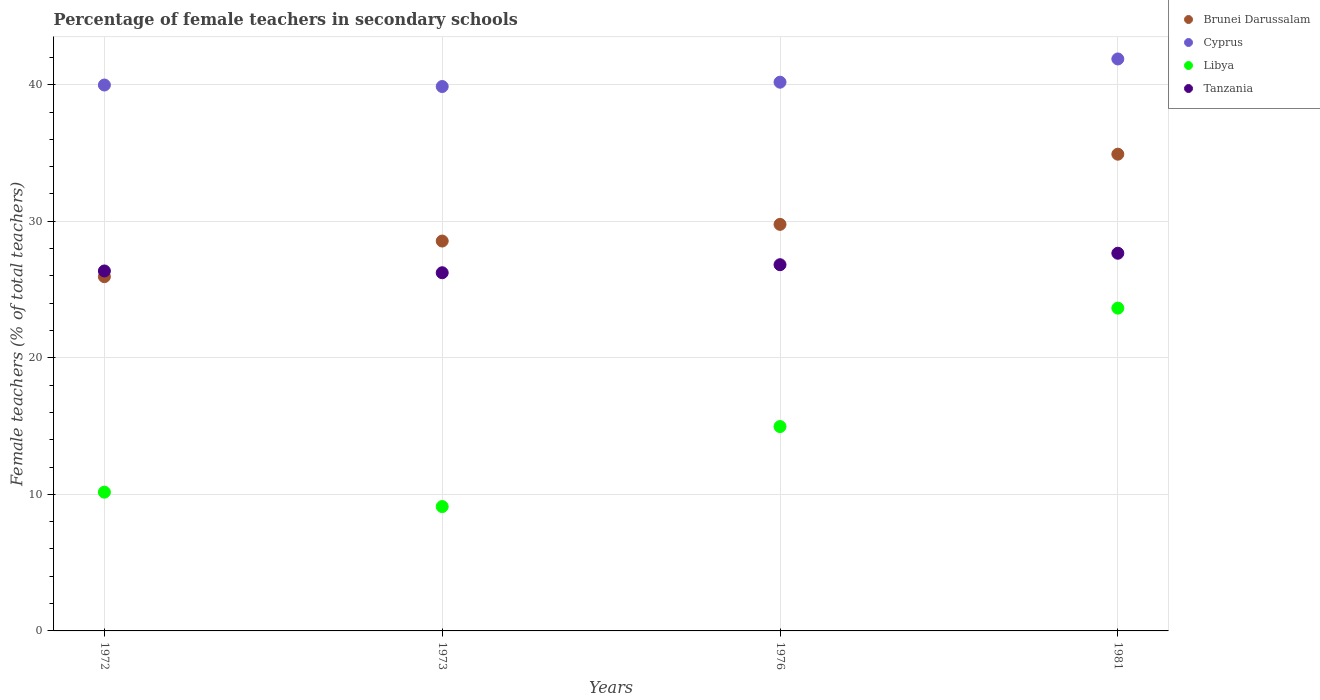Is the number of dotlines equal to the number of legend labels?
Provide a succinct answer. Yes. What is the percentage of female teachers in Cyprus in 1981?
Provide a succinct answer. 41.89. Across all years, what is the maximum percentage of female teachers in Cyprus?
Your answer should be very brief. 41.89. Across all years, what is the minimum percentage of female teachers in Libya?
Offer a very short reply. 9.11. What is the total percentage of female teachers in Tanzania in the graph?
Your answer should be compact. 107.08. What is the difference between the percentage of female teachers in Cyprus in 1973 and that in 1981?
Provide a short and direct response. -2.02. What is the difference between the percentage of female teachers in Cyprus in 1981 and the percentage of female teachers in Brunei Darussalam in 1976?
Your answer should be compact. 12.11. What is the average percentage of female teachers in Libya per year?
Your answer should be compact. 14.47. In the year 1976, what is the difference between the percentage of female teachers in Cyprus and percentage of female teachers in Libya?
Ensure brevity in your answer.  25.22. In how many years, is the percentage of female teachers in Tanzania greater than 30 %?
Provide a short and direct response. 0. What is the ratio of the percentage of female teachers in Brunei Darussalam in 1976 to that in 1981?
Ensure brevity in your answer.  0.85. Is the difference between the percentage of female teachers in Cyprus in 1973 and 1981 greater than the difference between the percentage of female teachers in Libya in 1973 and 1981?
Make the answer very short. Yes. What is the difference between the highest and the second highest percentage of female teachers in Cyprus?
Provide a succinct answer. 1.7. What is the difference between the highest and the lowest percentage of female teachers in Cyprus?
Make the answer very short. 2.02. In how many years, is the percentage of female teachers in Tanzania greater than the average percentage of female teachers in Tanzania taken over all years?
Keep it short and to the point. 2. Is it the case that in every year, the sum of the percentage of female teachers in Libya and percentage of female teachers in Cyprus  is greater than the sum of percentage of female teachers in Tanzania and percentage of female teachers in Brunei Darussalam?
Give a very brief answer. Yes. Is the percentage of female teachers in Libya strictly greater than the percentage of female teachers in Brunei Darussalam over the years?
Your answer should be compact. No. Is the percentage of female teachers in Libya strictly less than the percentage of female teachers in Tanzania over the years?
Offer a terse response. Yes. What is the difference between two consecutive major ticks on the Y-axis?
Make the answer very short. 10. Are the values on the major ticks of Y-axis written in scientific E-notation?
Provide a succinct answer. No. Does the graph contain grids?
Keep it short and to the point. Yes. How are the legend labels stacked?
Provide a succinct answer. Vertical. What is the title of the graph?
Your answer should be compact. Percentage of female teachers in secondary schools. Does "Dominica" appear as one of the legend labels in the graph?
Your response must be concise. No. What is the label or title of the Y-axis?
Make the answer very short. Female teachers (% of total teachers). What is the Female teachers (% of total teachers) in Brunei Darussalam in 1972?
Your answer should be compact. 25.94. What is the Female teachers (% of total teachers) in Cyprus in 1972?
Offer a terse response. 39.98. What is the Female teachers (% of total teachers) of Libya in 1972?
Your answer should be compact. 10.16. What is the Female teachers (% of total teachers) in Tanzania in 1972?
Offer a terse response. 26.36. What is the Female teachers (% of total teachers) in Brunei Darussalam in 1973?
Provide a succinct answer. 28.55. What is the Female teachers (% of total teachers) in Cyprus in 1973?
Your answer should be compact. 39.87. What is the Female teachers (% of total teachers) in Libya in 1973?
Provide a succinct answer. 9.11. What is the Female teachers (% of total teachers) of Tanzania in 1973?
Your response must be concise. 26.23. What is the Female teachers (% of total teachers) in Brunei Darussalam in 1976?
Make the answer very short. 29.77. What is the Female teachers (% of total teachers) in Cyprus in 1976?
Your answer should be compact. 40.19. What is the Female teachers (% of total teachers) of Libya in 1976?
Give a very brief answer. 14.97. What is the Female teachers (% of total teachers) of Tanzania in 1976?
Offer a very short reply. 26.82. What is the Female teachers (% of total teachers) of Brunei Darussalam in 1981?
Provide a short and direct response. 34.92. What is the Female teachers (% of total teachers) of Cyprus in 1981?
Make the answer very short. 41.89. What is the Female teachers (% of total teachers) in Libya in 1981?
Offer a very short reply. 23.64. What is the Female teachers (% of total teachers) in Tanzania in 1981?
Offer a terse response. 27.66. Across all years, what is the maximum Female teachers (% of total teachers) in Brunei Darussalam?
Offer a terse response. 34.92. Across all years, what is the maximum Female teachers (% of total teachers) of Cyprus?
Make the answer very short. 41.89. Across all years, what is the maximum Female teachers (% of total teachers) in Libya?
Keep it short and to the point. 23.64. Across all years, what is the maximum Female teachers (% of total teachers) of Tanzania?
Make the answer very short. 27.66. Across all years, what is the minimum Female teachers (% of total teachers) of Brunei Darussalam?
Provide a succinct answer. 25.94. Across all years, what is the minimum Female teachers (% of total teachers) in Cyprus?
Keep it short and to the point. 39.87. Across all years, what is the minimum Female teachers (% of total teachers) in Libya?
Keep it short and to the point. 9.11. Across all years, what is the minimum Female teachers (% of total teachers) of Tanzania?
Your response must be concise. 26.23. What is the total Female teachers (% of total teachers) in Brunei Darussalam in the graph?
Give a very brief answer. 119.19. What is the total Female teachers (% of total teachers) of Cyprus in the graph?
Your response must be concise. 161.93. What is the total Female teachers (% of total teachers) in Libya in the graph?
Make the answer very short. 57.88. What is the total Female teachers (% of total teachers) in Tanzania in the graph?
Offer a terse response. 107.08. What is the difference between the Female teachers (% of total teachers) of Brunei Darussalam in 1972 and that in 1973?
Make the answer very short. -2.61. What is the difference between the Female teachers (% of total teachers) of Cyprus in 1972 and that in 1973?
Your response must be concise. 0.11. What is the difference between the Female teachers (% of total teachers) in Libya in 1972 and that in 1973?
Ensure brevity in your answer.  1.05. What is the difference between the Female teachers (% of total teachers) of Tanzania in 1972 and that in 1973?
Your answer should be compact. 0.13. What is the difference between the Female teachers (% of total teachers) of Brunei Darussalam in 1972 and that in 1976?
Provide a short and direct response. -3.83. What is the difference between the Female teachers (% of total teachers) of Cyprus in 1972 and that in 1976?
Keep it short and to the point. -0.21. What is the difference between the Female teachers (% of total teachers) in Libya in 1972 and that in 1976?
Your response must be concise. -4.81. What is the difference between the Female teachers (% of total teachers) of Tanzania in 1972 and that in 1976?
Your answer should be compact. -0.46. What is the difference between the Female teachers (% of total teachers) in Brunei Darussalam in 1972 and that in 1981?
Ensure brevity in your answer.  -8.97. What is the difference between the Female teachers (% of total teachers) of Cyprus in 1972 and that in 1981?
Provide a succinct answer. -1.91. What is the difference between the Female teachers (% of total teachers) in Libya in 1972 and that in 1981?
Your answer should be very brief. -13.48. What is the difference between the Female teachers (% of total teachers) in Tanzania in 1972 and that in 1981?
Your response must be concise. -1.3. What is the difference between the Female teachers (% of total teachers) of Brunei Darussalam in 1973 and that in 1976?
Offer a very short reply. -1.22. What is the difference between the Female teachers (% of total teachers) in Cyprus in 1973 and that in 1976?
Offer a terse response. -0.32. What is the difference between the Female teachers (% of total teachers) of Libya in 1973 and that in 1976?
Provide a succinct answer. -5.86. What is the difference between the Female teachers (% of total teachers) of Tanzania in 1973 and that in 1976?
Your response must be concise. -0.59. What is the difference between the Female teachers (% of total teachers) in Brunei Darussalam in 1973 and that in 1981?
Ensure brevity in your answer.  -6.36. What is the difference between the Female teachers (% of total teachers) of Cyprus in 1973 and that in 1981?
Provide a succinct answer. -2.02. What is the difference between the Female teachers (% of total teachers) of Libya in 1973 and that in 1981?
Offer a very short reply. -14.53. What is the difference between the Female teachers (% of total teachers) of Tanzania in 1973 and that in 1981?
Provide a short and direct response. -1.43. What is the difference between the Female teachers (% of total teachers) of Brunei Darussalam in 1976 and that in 1981?
Keep it short and to the point. -5.14. What is the difference between the Female teachers (% of total teachers) in Cyprus in 1976 and that in 1981?
Offer a terse response. -1.7. What is the difference between the Female teachers (% of total teachers) of Libya in 1976 and that in 1981?
Make the answer very short. -8.67. What is the difference between the Female teachers (% of total teachers) of Tanzania in 1976 and that in 1981?
Give a very brief answer. -0.84. What is the difference between the Female teachers (% of total teachers) of Brunei Darussalam in 1972 and the Female teachers (% of total teachers) of Cyprus in 1973?
Offer a terse response. -13.93. What is the difference between the Female teachers (% of total teachers) of Brunei Darussalam in 1972 and the Female teachers (% of total teachers) of Libya in 1973?
Keep it short and to the point. 16.84. What is the difference between the Female teachers (% of total teachers) of Brunei Darussalam in 1972 and the Female teachers (% of total teachers) of Tanzania in 1973?
Your response must be concise. -0.29. What is the difference between the Female teachers (% of total teachers) of Cyprus in 1972 and the Female teachers (% of total teachers) of Libya in 1973?
Make the answer very short. 30.87. What is the difference between the Female teachers (% of total teachers) of Cyprus in 1972 and the Female teachers (% of total teachers) of Tanzania in 1973?
Offer a very short reply. 13.75. What is the difference between the Female teachers (% of total teachers) in Libya in 1972 and the Female teachers (% of total teachers) in Tanzania in 1973?
Your answer should be compact. -16.07. What is the difference between the Female teachers (% of total teachers) in Brunei Darussalam in 1972 and the Female teachers (% of total teachers) in Cyprus in 1976?
Provide a succinct answer. -14.24. What is the difference between the Female teachers (% of total teachers) of Brunei Darussalam in 1972 and the Female teachers (% of total teachers) of Libya in 1976?
Provide a succinct answer. 10.98. What is the difference between the Female teachers (% of total teachers) of Brunei Darussalam in 1972 and the Female teachers (% of total teachers) of Tanzania in 1976?
Make the answer very short. -0.88. What is the difference between the Female teachers (% of total teachers) of Cyprus in 1972 and the Female teachers (% of total teachers) of Libya in 1976?
Provide a short and direct response. 25.01. What is the difference between the Female teachers (% of total teachers) of Cyprus in 1972 and the Female teachers (% of total teachers) of Tanzania in 1976?
Keep it short and to the point. 13.16. What is the difference between the Female teachers (% of total teachers) of Libya in 1972 and the Female teachers (% of total teachers) of Tanzania in 1976?
Offer a terse response. -16.66. What is the difference between the Female teachers (% of total teachers) of Brunei Darussalam in 1972 and the Female teachers (% of total teachers) of Cyprus in 1981?
Offer a terse response. -15.95. What is the difference between the Female teachers (% of total teachers) of Brunei Darussalam in 1972 and the Female teachers (% of total teachers) of Libya in 1981?
Give a very brief answer. 2.3. What is the difference between the Female teachers (% of total teachers) in Brunei Darussalam in 1972 and the Female teachers (% of total teachers) in Tanzania in 1981?
Offer a terse response. -1.72. What is the difference between the Female teachers (% of total teachers) in Cyprus in 1972 and the Female teachers (% of total teachers) in Libya in 1981?
Your response must be concise. 16.34. What is the difference between the Female teachers (% of total teachers) of Cyprus in 1972 and the Female teachers (% of total teachers) of Tanzania in 1981?
Your answer should be compact. 12.32. What is the difference between the Female teachers (% of total teachers) of Libya in 1972 and the Female teachers (% of total teachers) of Tanzania in 1981?
Your answer should be compact. -17.5. What is the difference between the Female teachers (% of total teachers) in Brunei Darussalam in 1973 and the Female teachers (% of total teachers) in Cyprus in 1976?
Ensure brevity in your answer.  -11.63. What is the difference between the Female teachers (% of total teachers) of Brunei Darussalam in 1973 and the Female teachers (% of total teachers) of Libya in 1976?
Your response must be concise. 13.59. What is the difference between the Female teachers (% of total teachers) in Brunei Darussalam in 1973 and the Female teachers (% of total teachers) in Tanzania in 1976?
Your answer should be very brief. 1.73. What is the difference between the Female teachers (% of total teachers) in Cyprus in 1973 and the Female teachers (% of total teachers) in Libya in 1976?
Provide a succinct answer. 24.9. What is the difference between the Female teachers (% of total teachers) of Cyprus in 1973 and the Female teachers (% of total teachers) of Tanzania in 1976?
Your answer should be compact. 13.05. What is the difference between the Female teachers (% of total teachers) of Libya in 1973 and the Female teachers (% of total teachers) of Tanzania in 1976?
Keep it short and to the point. -17.71. What is the difference between the Female teachers (% of total teachers) in Brunei Darussalam in 1973 and the Female teachers (% of total teachers) in Cyprus in 1981?
Give a very brief answer. -13.34. What is the difference between the Female teachers (% of total teachers) of Brunei Darussalam in 1973 and the Female teachers (% of total teachers) of Libya in 1981?
Your answer should be compact. 4.91. What is the difference between the Female teachers (% of total teachers) in Brunei Darussalam in 1973 and the Female teachers (% of total teachers) in Tanzania in 1981?
Provide a short and direct response. 0.89. What is the difference between the Female teachers (% of total teachers) in Cyprus in 1973 and the Female teachers (% of total teachers) in Libya in 1981?
Your answer should be compact. 16.23. What is the difference between the Female teachers (% of total teachers) of Cyprus in 1973 and the Female teachers (% of total teachers) of Tanzania in 1981?
Offer a very short reply. 12.21. What is the difference between the Female teachers (% of total teachers) in Libya in 1973 and the Female teachers (% of total teachers) in Tanzania in 1981?
Provide a short and direct response. -18.55. What is the difference between the Female teachers (% of total teachers) in Brunei Darussalam in 1976 and the Female teachers (% of total teachers) in Cyprus in 1981?
Ensure brevity in your answer.  -12.11. What is the difference between the Female teachers (% of total teachers) of Brunei Darussalam in 1976 and the Female teachers (% of total teachers) of Libya in 1981?
Give a very brief answer. 6.13. What is the difference between the Female teachers (% of total teachers) of Brunei Darussalam in 1976 and the Female teachers (% of total teachers) of Tanzania in 1981?
Give a very brief answer. 2.11. What is the difference between the Female teachers (% of total teachers) in Cyprus in 1976 and the Female teachers (% of total teachers) in Libya in 1981?
Give a very brief answer. 16.55. What is the difference between the Female teachers (% of total teachers) in Cyprus in 1976 and the Female teachers (% of total teachers) in Tanzania in 1981?
Give a very brief answer. 12.53. What is the difference between the Female teachers (% of total teachers) of Libya in 1976 and the Female teachers (% of total teachers) of Tanzania in 1981?
Your answer should be very brief. -12.69. What is the average Female teachers (% of total teachers) of Brunei Darussalam per year?
Offer a terse response. 29.8. What is the average Female teachers (% of total teachers) in Cyprus per year?
Ensure brevity in your answer.  40.48. What is the average Female teachers (% of total teachers) in Libya per year?
Your answer should be very brief. 14.47. What is the average Female teachers (% of total teachers) of Tanzania per year?
Keep it short and to the point. 26.77. In the year 1972, what is the difference between the Female teachers (% of total teachers) in Brunei Darussalam and Female teachers (% of total teachers) in Cyprus?
Offer a very short reply. -14.04. In the year 1972, what is the difference between the Female teachers (% of total teachers) of Brunei Darussalam and Female teachers (% of total teachers) of Libya?
Provide a succinct answer. 15.78. In the year 1972, what is the difference between the Female teachers (% of total teachers) in Brunei Darussalam and Female teachers (% of total teachers) in Tanzania?
Offer a very short reply. -0.42. In the year 1972, what is the difference between the Female teachers (% of total teachers) in Cyprus and Female teachers (% of total teachers) in Libya?
Make the answer very short. 29.82. In the year 1972, what is the difference between the Female teachers (% of total teachers) of Cyprus and Female teachers (% of total teachers) of Tanzania?
Make the answer very short. 13.62. In the year 1972, what is the difference between the Female teachers (% of total teachers) in Libya and Female teachers (% of total teachers) in Tanzania?
Offer a very short reply. -16.2. In the year 1973, what is the difference between the Female teachers (% of total teachers) of Brunei Darussalam and Female teachers (% of total teachers) of Cyprus?
Make the answer very short. -11.32. In the year 1973, what is the difference between the Female teachers (% of total teachers) in Brunei Darussalam and Female teachers (% of total teachers) in Libya?
Offer a very short reply. 19.45. In the year 1973, what is the difference between the Female teachers (% of total teachers) in Brunei Darussalam and Female teachers (% of total teachers) in Tanzania?
Make the answer very short. 2.32. In the year 1973, what is the difference between the Female teachers (% of total teachers) of Cyprus and Female teachers (% of total teachers) of Libya?
Offer a terse response. 30.76. In the year 1973, what is the difference between the Female teachers (% of total teachers) in Cyprus and Female teachers (% of total teachers) in Tanzania?
Your response must be concise. 13.64. In the year 1973, what is the difference between the Female teachers (% of total teachers) in Libya and Female teachers (% of total teachers) in Tanzania?
Offer a very short reply. -17.12. In the year 1976, what is the difference between the Female teachers (% of total teachers) in Brunei Darussalam and Female teachers (% of total teachers) in Cyprus?
Keep it short and to the point. -10.41. In the year 1976, what is the difference between the Female teachers (% of total teachers) in Brunei Darussalam and Female teachers (% of total teachers) in Libya?
Provide a short and direct response. 14.81. In the year 1976, what is the difference between the Female teachers (% of total teachers) of Brunei Darussalam and Female teachers (% of total teachers) of Tanzania?
Provide a succinct answer. 2.95. In the year 1976, what is the difference between the Female teachers (% of total teachers) in Cyprus and Female teachers (% of total teachers) in Libya?
Ensure brevity in your answer.  25.22. In the year 1976, what is the difference between the Female teachers (% of total teachers) in Cyprus and Female teachers (% of total teachers) in Tanzania?
Give a very brief answer. 13.37. In the year 1976, what is the difference between the Female teachers (% of total teachers) of Libya and Female teachers (% of total teachers) of Tanzania?
Give a very brief answer. -11.85. In the year 1981, what is the difference between the Female teachers (% of total teachers) of Brunei Darussalam and Female teachers (% of total teachers) of Cyprus?
Your response must be concise. -6.97. In the year 1981, what is the difference between the Female teachers (% of total teachers) of Brunei Darussalam and Female teachers (% of total teachers) of Libya?
Provide a succinct answer. 11.28. In the year 1981, what is the difference between the Female teachers (% of total teachers) of Brunei Darussalam and Female teachers (% of total teachers) of Tanzania?
Your answer should be compact. 7.25. In the year 1981, what is the difference between the Female teachers (% of total teachers) in Cyprus and Female teachers (% of total teachers) in Libya?
Your response must be concise. 18.25. In the year 1981, what is the difference between the Female teachers (% of total teachers) in Cyprus and Female teachers (% of total teachers) in Tanzania?
Your answer should be compact. 14.23. In the year 1981, what is the difference between the Female teachers (% of total teachers) of Libya and Female teachers (% of total teachers) of Tanzania?
Make the answer very short. -4.02. What is the ratio of the Female teachers (% of total teachers) of Brunei Darussalam in 1972 to that in 1973?
Provide a succinct answer. 0.91. What is the ratio of the Female teachers (% of total teachers) of Cyprus in 1972 to that in 1973?
Make the answer very short. 1. What is the ratio of the Female teachers (% of total teachers) of Libya in 1972 to that in 1973?
Your response must be concise. 1.12. What is the ratio of the Female teachers (% of total teachers) in Tanzania in 1972 to that in 1973?
Make the answer very short. 1. What is the ratio of the Female teachers (% of total teachers) in Brunei Darussalam in 1972 to that in 1976?
Offer a terse response. 0.87. What is the ratio of the Female teachers (% of total teachers) of Cyprus in 1972 to that in 1976?
Offer a terse response. 0.99. What is the ratio of the Female teachers (% of total teachers) of Libya in 1972 to that in 1976?
Ensure brevity in your answer.  0.68. What is the ratio of the Female teachers (% of total teachers) of Tanzania in 1972 to that in 1976?
Keep it short and to the point. 0.98. What is the ratio of the Female teachers (% of total teachers) in Brunei Darussalam in 1972 to that in 1981?
Your response must be concise. 0.74. What is the ratio of the Female teachers (% of total teachers) of Cyprus in 1972 to that in 1981?
Offer a terse response. 0.95. What is the ratio of the Female teachers (% of total teachers) in Libya in 1972 to that in 1981?
Give a very brief answer. 0.43. What is the ratio of the Female teachers (% of total teachers) in Tanzania in 1972 to that in 1981?
Ensure brevity in your answer.  0.95. What is the ratio of the Female teachers (% of total teachers) of Brunei Darussalam in 1973 to that in 1976?
Offer a terse response. 0.96. What is the ratio of the Female teachers (% of total teachers) in Libya in 1973 to that in 1976?
Provide a succinct answer. 0.61. What is the ratio of the Female teachers (% of total teachers) of Tanzania in 1973 to that in 1976?
Make the answer very short. 0.98. What is the ratio of the Female teachers (% of total teachers) of Brunei Darussalam in 1973 to that in 1981?
Offer a terse response. 0.82. What is the ratio of the Female teachers (% of total teachers) in Cyprus in 1973 to that in 1981?
Provide a short and direct response. 0.95. What is the ratio of the Female teachers (% of total teachers) of Libya in 1973 to that in 1981?
Give a very brief answer. 0.39. What is the ratio of the Female teachers (% of total teachers) of Tanzania in 1973 to that in 1981?
Ensure brevity in your answer.  0.95. What is the ratio of the Female teachers (% of total teachers) of Brunei Darussalam in 1976 to that in 1981?
Keep it short and to the point. 0.85. What is the ratio of the Female teachers (% of total teachers) in Cyprus in 1976 to that in 1981?
Keep it short and to the point. 0.96. What is the ratio of the Female teachers (% of total teachers) of Libya in 1976 to that in 1981?
Provide a succinct answer. 0.63. What is the ratio of the Female teachers (% of total teachers) in Tanzania in 1976 to that in 1981?
Offer a terse response. 0.97. What is the difference between the highest and the second highest Female teachers (% of total teachers) in Brunei Darussalam?
Your response must be concise. 5.14. What is the difference between the highest and the second highest Female teachers (% of total teachers) in Cyprus?
Your response must be concise. 1.7. What is the difference between the highest and the second highest Female teachers (% of total teachers) in Libya?
Provide a succinct answer. 8.67. What is the difference between the highest and the second highest Female teachers (% of total teachers) in Tanzania?
Your answer should be compact. 0.84. What is the difference between the highest and the lowest Female teachers (% of total teachers) of Brunei Darussalam?
Provide a short and direct response. 8.97. What is the difference between the highest and the lowest Female teachers (% of total teachers) of Cyprus?
Your response must be concise. 2.02. What is the difference between the highest and the lowest Female teachers (% of total teachers) of Libya?
Give a very brief answer. 14.53. What is the difference between the highest and the lowest Female teachers (% of total teachers) in Tanzania?
Give a very brief answer. 1.43. 